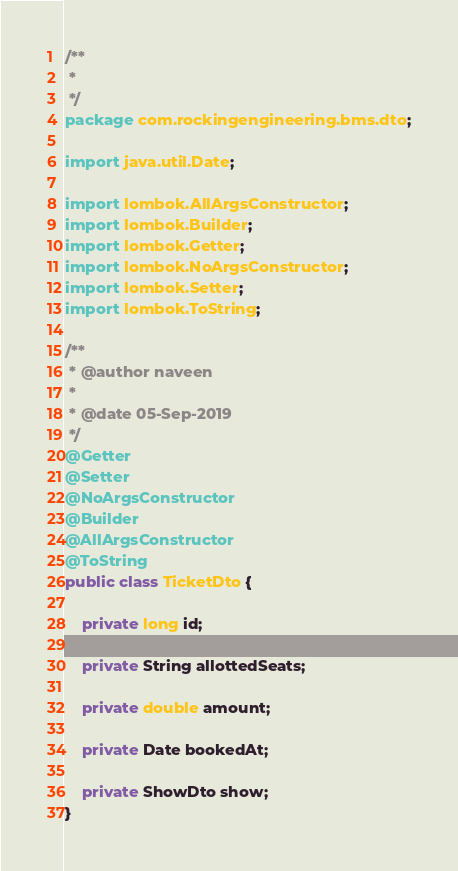Convert code to text. <code><loc_0><loc_0><loc_500><loc_500><_Java_>/**
 * 
 */
package com.rockingengineering.bms.dto;

import java.util.Date;

import lombok.AllArgsConstructor;
import lombok.Builder;
import lombok.Getter;
import lombok.NoArgsConstructor;
import lombok.Setter;
import lombok.ToString;

/**
 * @author naveen
 *
 * @date 05-Sep-2019
 */
@Getter
@Setter
@NoArgsConstructor
@Builder
@AllArgsConstructor
@ToString
public class TicketDto {

	private long id;

	private String allottedSeats;

	private double amount;

	private Date bookedAt;

	private ShowDto show;
}</code> 